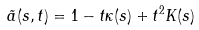Convert formula to latex. <formula><loc_0><loc_0><loc_500><loc_500>\tilde { a } ( s , t ) = 1 - t \kappa ( s ) + t ^ { 2 } K ( s )</formula> 